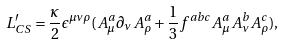Convert formula to latex. <formula><loc_0><loc_0><loc_500><loc_500>L _ { C S } ^ { \prime } = \frac { \kappa } { 2 } \epsilon ^ { \mu \nu \rho } ( A _ { \mu } ^ { a } \partial _ { \nu } A _ { \rho } ^ { a } + \frac { 1 } { 3 } f ^ { a b c } A _ { \mu } ^ { a } A _ { \nu } ^ { b } A _ { \rho } ^ { c } ) ,</formula> 